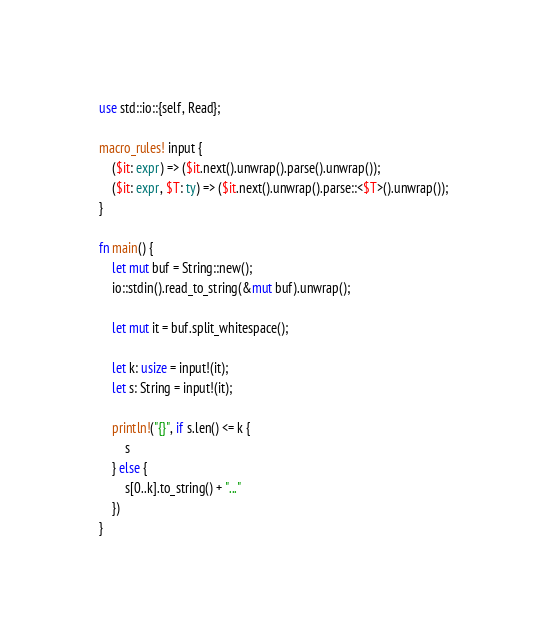<code> <loc_0><loc_0><loc_500><loc_500><_Rust_>use std::io::{self, Read};

macro_rules! input {
    ($it: expr) => ($it.next().unwrap().parse().unwrap());
    ($it: expr, $T: ty) => ($it.next().unwrap().parse::<$T>().unwrap());
}

fn main() {
    let mut buf = String::new();
    io::stdin().read_to_string(&mut buf).unwrap();

    let mut it = buf.split_whitespace();

    let k: usize = input!(it);
    let s: String = input!(it);

    println!("{}", if s.len() <= k {
        s
    } else {
        s[0..k].to_string() + "..."
    })
}</code> 